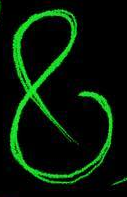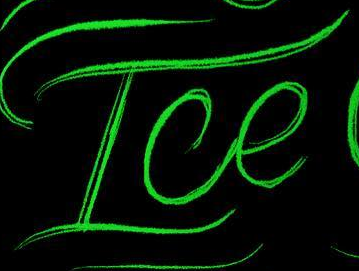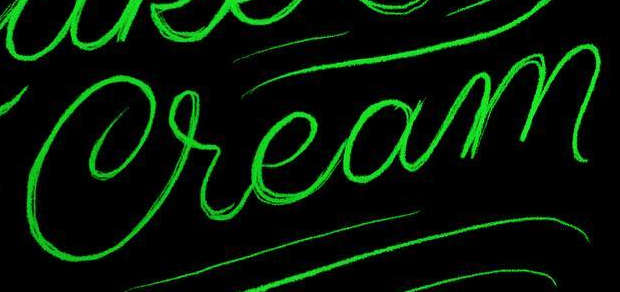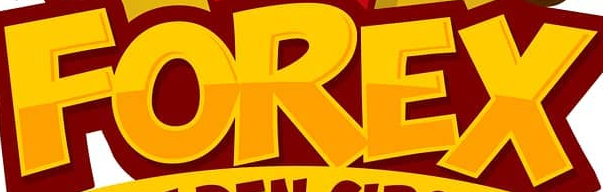Transcribe the words shown in these images in order, separated by a semicolon. &; Ice; Cream; FOREX 